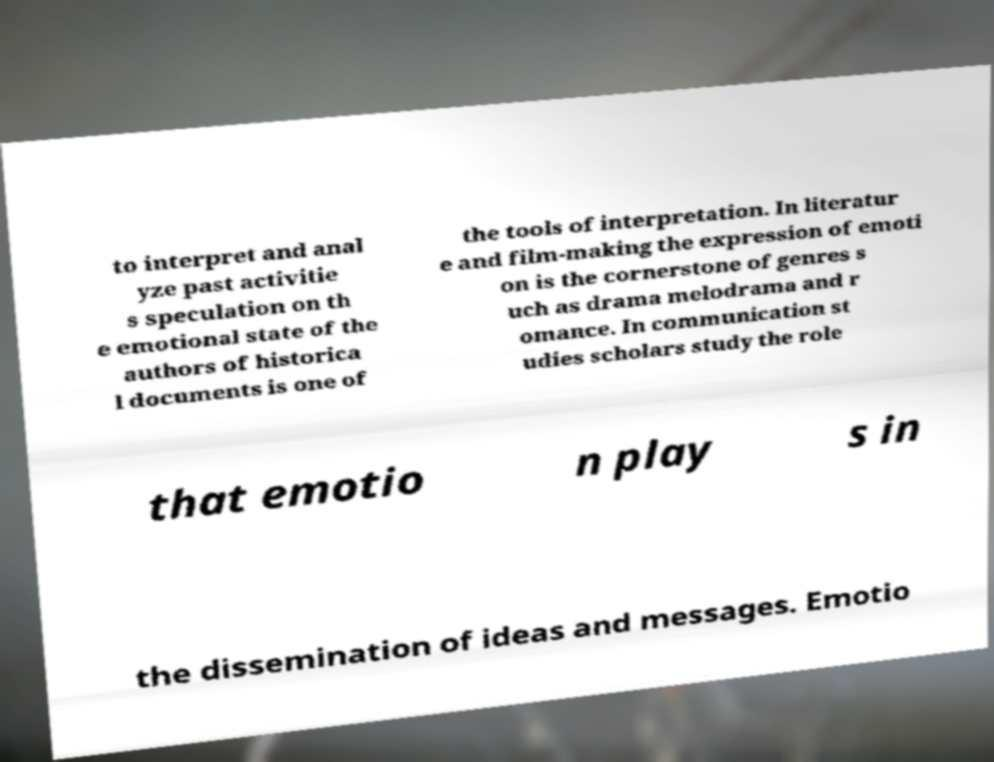I need the written content from this picture converted into text. Can you do that? to interpret and anal yze past activitie s speculation on th e emotional state of the authors of historica l documents is one of the tools of interpretation. In literatur e and film-making the expression of emoti on is the cornerstone of genres s uch as drama melodrama and r omance. In communication st udies scholars study the role that emotio n play s in the dissemination of ideas and messages. Emotio 